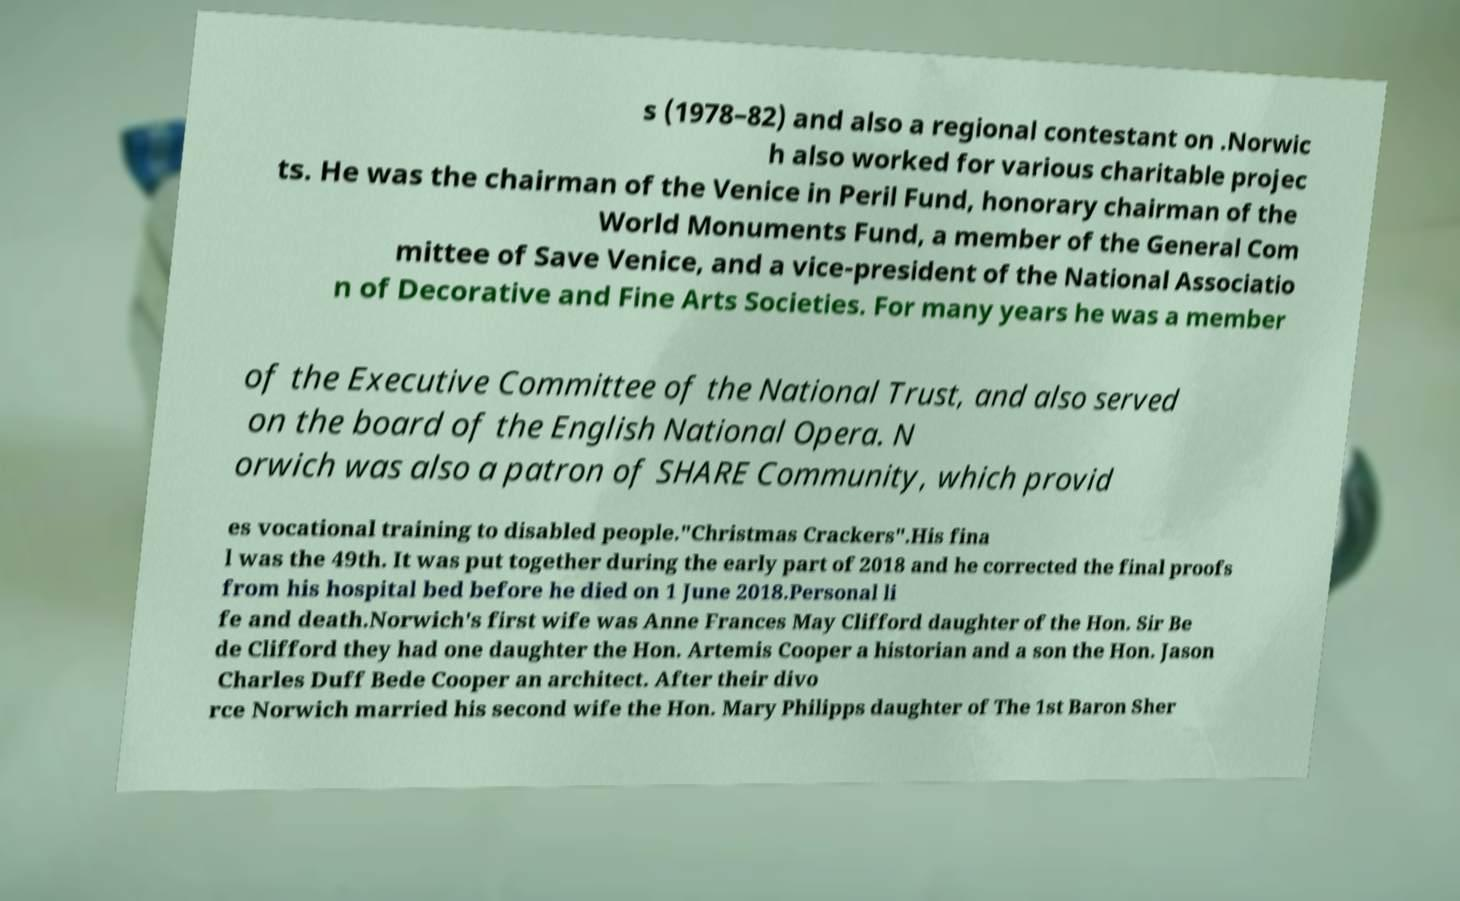Can you accurately transcribe the text from the provided image for me? s (1978–82) and also a regional contestant on .Norwic h also worked for various charitable projec ts. He was the chairman of the Venice in Peril Fund, honorary chairman of the World Monuments Fund, a member of the General Com mittee of Save Venice, and a vice-president of the National Associatio n of Decorative and Fine Arts Societies. For many years he was a member of the Executive Committee of the National Trust, and also served on the board of the English National Opera. N orwich was also a patron of SHARE Community, which provid es vocational training to disabled people."Christmas Crackers".His fina l was the 49th. It was put together during the early part of 2018 and he corrected the final proofs from his hospital bed before he died on 1 June 2018.Personal li fe and death.Norwich's first wife was Anne Frances May Clifford daughter of the Hon. Sir Be de Clifford they had one daughter the Hon. Artemis Cooper a historian and a son the Hon. Jason Charles Duff Bede Cooper an architect. After their divo rce Norwich married his second wife the Hon. Mary Philipps daughter of The 1st Baron Sher 